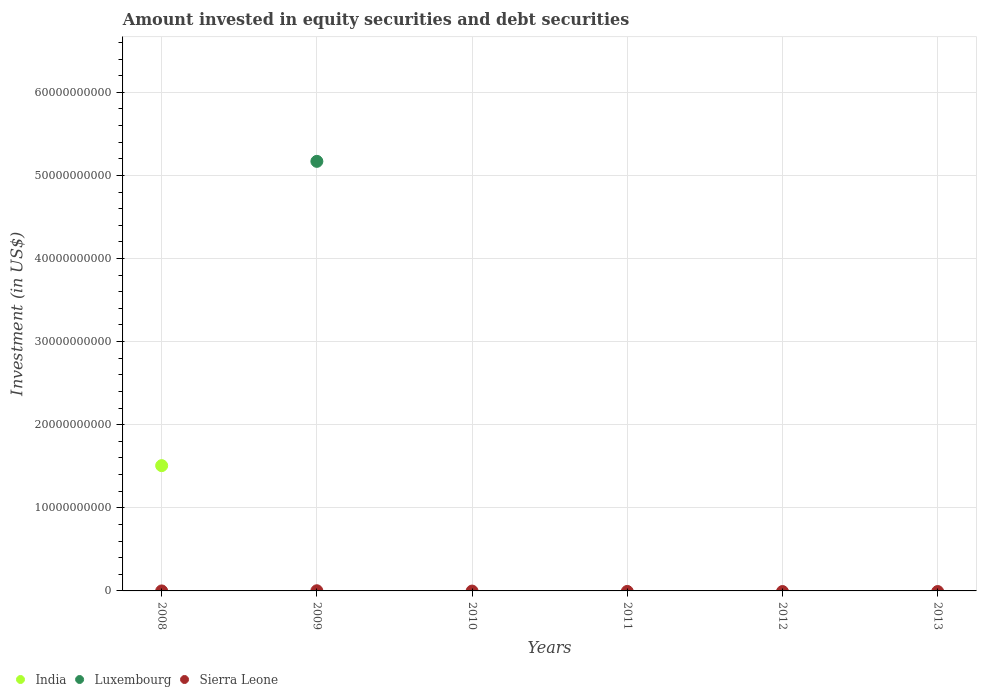What is the amount invested in equity securities and debt securities in Sierra Leone in 2013?
Keep it short and to the point. 0. Across all years, what is the maximum amount invested in equity securities and debt securities in Luxembourg?
Your answer should be compact. 5.17e+1. Across all years, what is the minimum amount invested in equity securities and debt securities in Luxembourg?
Give a very brief answer. 0. In which year was the amount invested in equity securities and debt securities in India maximum?
Ensure brevity in your answer.  2008. What is the total amount invested in equity securities and debt securities in India in the graph?
Keep it short and to the point. 1.51e+1. What is the difference between the amount invested in equity securities and debt securities in Luxembourg in 2013 and the amount invested in equity securities and debt securities in Sierra Leone in 2009?
Your answer should be compact. -2.03e+07. What is the average amount invested in equity securities and debt securities in Luxembourg per year?
Ensure brevity in your answer.  8.61e+09. What is the difference between the highest and the lowest amount invested in equity securities and debt securities in Luxembourg?
Offer a terse response. 5.17e+1. Does the amount invested in equity securities and debt securities in Luxembourg monotonically increase over the years?
Provide a short and direct response. No. Is the amount invested in equity securities and debt securities in Sierra Leone strictly less than the amount invested in equity securities and debt securities in India over the years?
Provide a succinct answer. No. How many dotlines are there?
Offer a terse response. 3. How many years are there in the graph?
Ensure brevity in your answer.  6. What is the difference between two consecutive major ticks on the Y-axis?
Give a very brief answer. 1.00e+1. Are the values on the major ticks of Y-axis written in scientific E-notation?
Make the answer very short. No. Does the graph contain any zero values?
Give a very brief answer. Yes. Does the graph contain grids?
Your answer should be very brief. Yes. Where does the legend appear in the graph?
Your response must be concise. Bottom left. How are the legend labels stacked?
Make the answer very short. Horizontal. What is the title of the graph?
Make the answer very short. Amount invested in equity securities and debt securities. What is the label or title of the X-axis?
Your answer should be very brief. Years. What is the label or title of the Y-axis?
Make the answer very short. Investment (in US$). What is the Investment (in US$) of India in 2008?
Provide a succinct answer. 1.51e+1. What is the Investment (in US$) of Luxembourg in 2008?
Provide a short and direct response. 0. What is the Investment (in US$) in India in 2009?
Provide a succinct answer. 0. What is the Investment (in US$) of Luxembourg in 2009?
Provide a succinct answer. 5.17e+1. What is the Investment (in US$) of Sierra Leone in 2009?
Make the answer very short. 2.03e+07. What is the Investment (in US$) of India in 2010?
Ensure brevity in your answer.  0. What is the Investment (in US$) in India in 2011?
Keep it short and to the point. 0. What is the Investment (in US$) in India in 2012?
Provide a succinct answer. 0. What is the Investment (in US$) in Sierra Leone in 2012?
Keep it short and to the point. 0. Across all years, what is the maximum Investment (in US$) of India?
Keep it short and to the point. 1.51e+1. Across all years, what is the maximum Investment (in US$) in Luxembourg?
Offer a terse response. 5.17e+1. Across all years, what is the maximum Investment (in US$) of Sierra Leone?
Your response must be concise. 2.03e+07. Across all years, what is the minimum Investment (in US$) in Luxembourg?
Offer a very short reply. 0. What is the total Investment (in US$) of India in the graph?
Provide a succinct answer. 1.51e+1. What is the total Investment (in US$) of Luxembourg in the graph?
Provide a short and direct response. 5.17e+1. What is the total Investment (in US$) of Sierra Leone in the graph?
Provide a short and direct response. 2.03e+07. What is the difference between the Investment (in US$) of India in 2008 and the Investment (in US$) of Luxembourg in 2009?
Your response must be concise. -3.66e+1. What is the difference between the Investment (in US$) of India in 2008 and the Investment (in US$) of Sierra Leone in 2009?
Your answer should be compact. 1.51e+1. What is the average Investment (in US$) in India per year?
Your answer should be compact. 2.51e+09. What is the average Investment (in US$) of Luxembourg per year?
Make the answer very short. 8.61e+09. What is the average Investment (in US$) in Sierra Leone per year?
Your answer should be very brief. 3.39e+06. In the year 2009, what is the difference between the Investment (in US$) in Luxembourg and Investment (in US$) in Sierra Leone?
Give a very brief answer. 5.17e+1. What is the difference between the highest and the lowest Investment (in US$) in India?
Make the answer very short. 1.51e+1. What is the difference between the highest and the lowest Investment (in US$) of Luxembourg?
Your answer should be compact. 5.17e+1. What is the difference between the highest and the lowest Investment (in US$) of Sierra Leone?
Provide a succinct answer. 2.03e+07. 